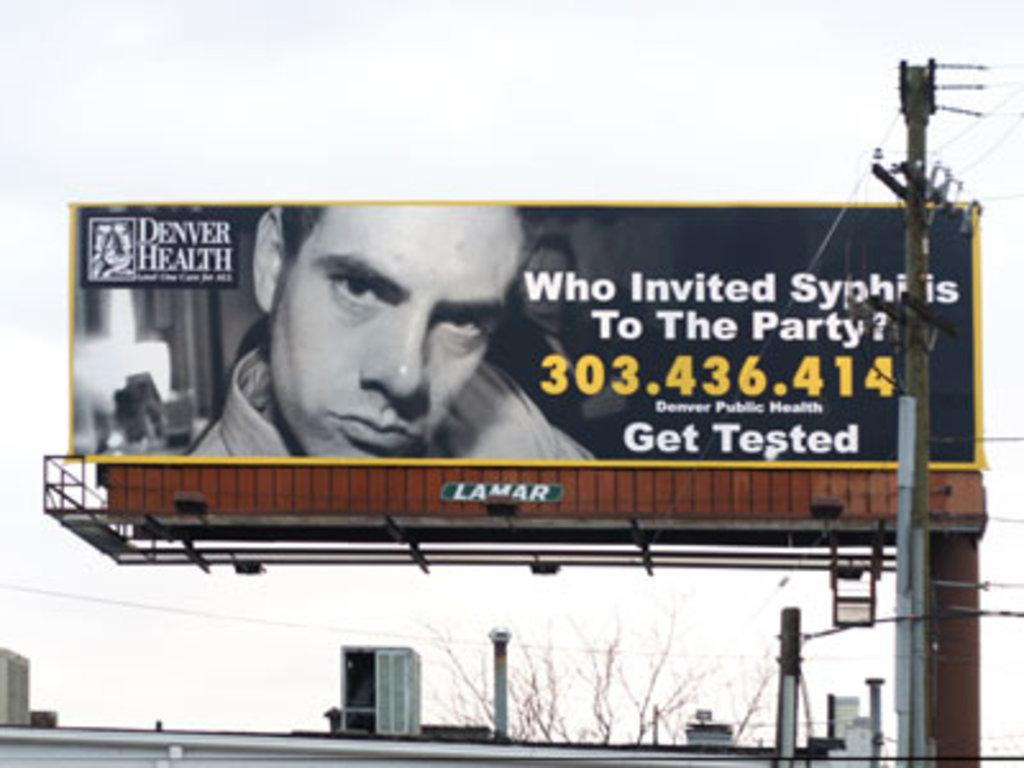<image>
Provide a brief description of the given image. The billboard is about syphilis and from Denver Heath. 